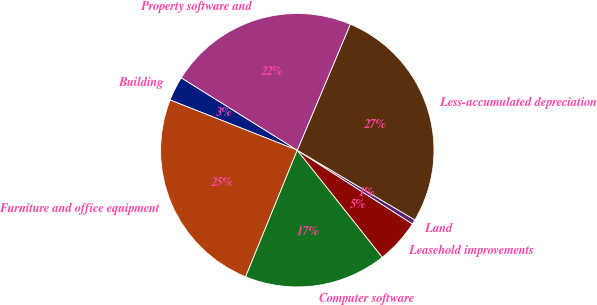<chart> <loc_0><loc_0><loc_500><loc_500><pie_chart><fcel>Building<fcel>Furniture and office equipment<fcel>Computer software<fcel>Leasehold improvements<fcel>Land<fcel>Less-accumulated depreciation<fcel>Property software and<nl><fcel>2.9%<fcel>24.82%<fcel>16.85%<fcel>5.26%<fcel>0.54%<fcel>27.18%<fcel>22.46%<nl></chart> 